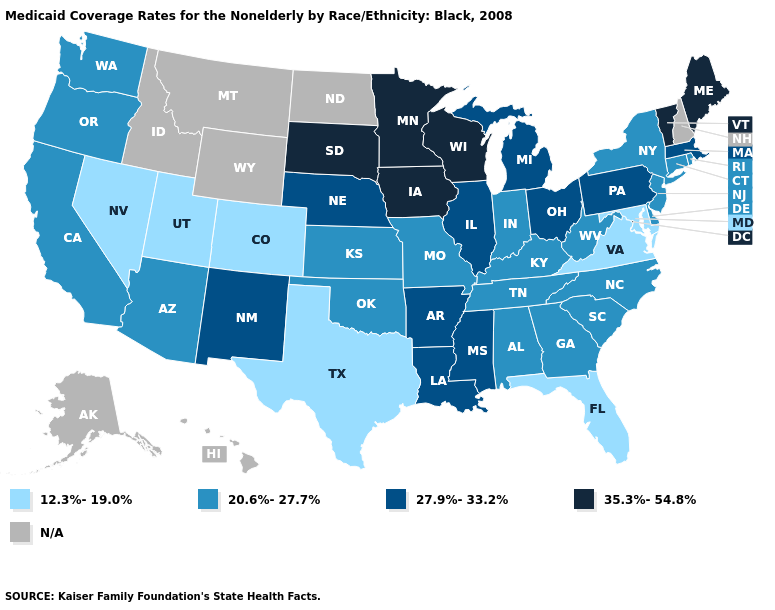Name the states that have a value in the range 27.9%-33.2%?
Concise answer only. Arkansas, Illinois, Louisiana, Massachusetts, Michigan, Mississippi, Nebraska, New Mexico, Ohio, Pennsylvania. What is the value of Arkansas?
Give a very brief answer. 27.9%-33.2%. What is the highest value in the USA?
Quick response, please. 35.3%-54.8%. What is the value of Illinois?
Short answer required. 27.9%-33.2%. Name the states that have a value in the range 20.6%-27.7%?
Short answer required. Alabama, Arizona, California, Connecticut, Delaware, Georgia, Indiana, Kansas, Kentucky, Missouri, New Jersey, New York, North Carolina, Oklahoma, Oregon, Rhode Island, South Carolina, Tennessee, Washington, West Virginia. What is the highest value in states that border Nebraska?
Write a very short answer. 35.3%-54.8%. Name the states that have a value in the range 12.3%-19.0%?
Keep it brief. Colorado, Florida, Maryland, Nevada, Texas, Utah, Virginia. What is the value of Florida?
Short answer required. 12.3%-19.0%. Name the states that have a value in the range 12.3%-19.0%?
Concise answer only. Colorado, Florida, Maryland, Nevada, Texas, Utah, Virginia. Name the states that have a value in the range N/A?
Write a very short answer. Alaska, Hawaii, Idaho, Montana, New Hampshire, North Dakota, Wyoming. What is the value of Texas?
Concise answer only. 12.3%-19.0%. Name the states that have a value in the range 35.3%-54.8%?
Quick response, please. Iowa, Maine, Minnesota, South Dakota, Vermont, Wisconsin. Name the states that have a value in the range 12.3%-19.0%?
Be succinct. Colorado, Florida, Maryland, Nevada, Texas, Utah, Virginia. Among the states that border New Jersey , which have the lowest value?
Answer briefly. Delaware, New York. 